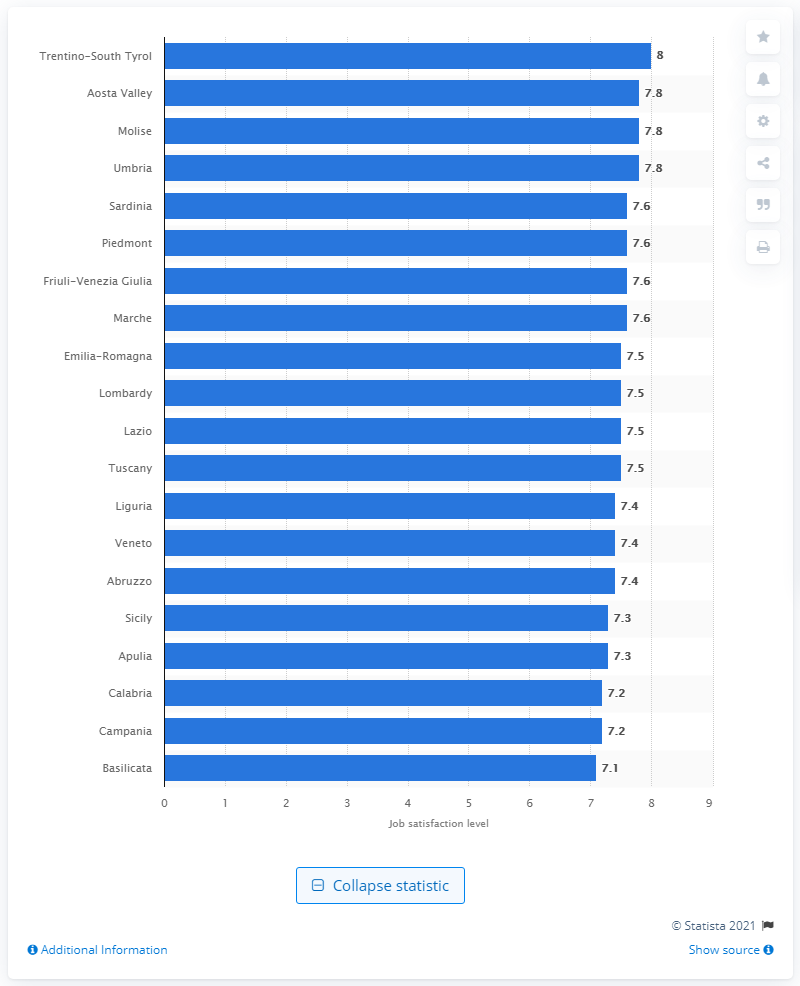Outline some significant characteristics in this image. The highest job satisfaction level among Italian employees was recorded in Trentino-South Tyrol in the second quarter of 2020. 